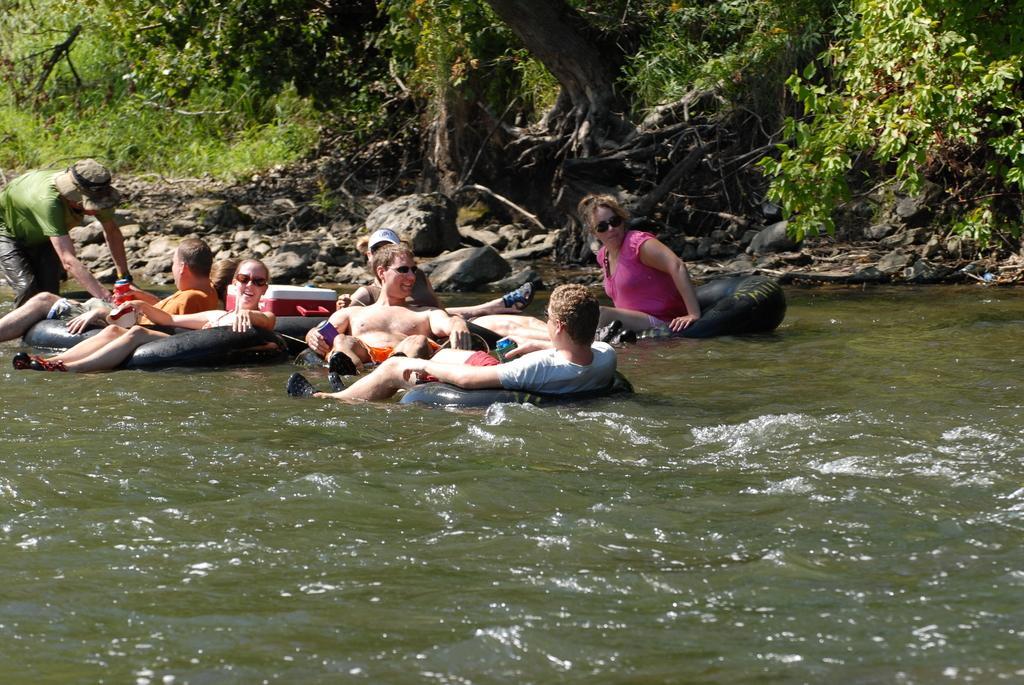Please provide a concise description of this image. In this image we can see persons in balloons sailing on the water. In the background we can see trees, plants and stones. 